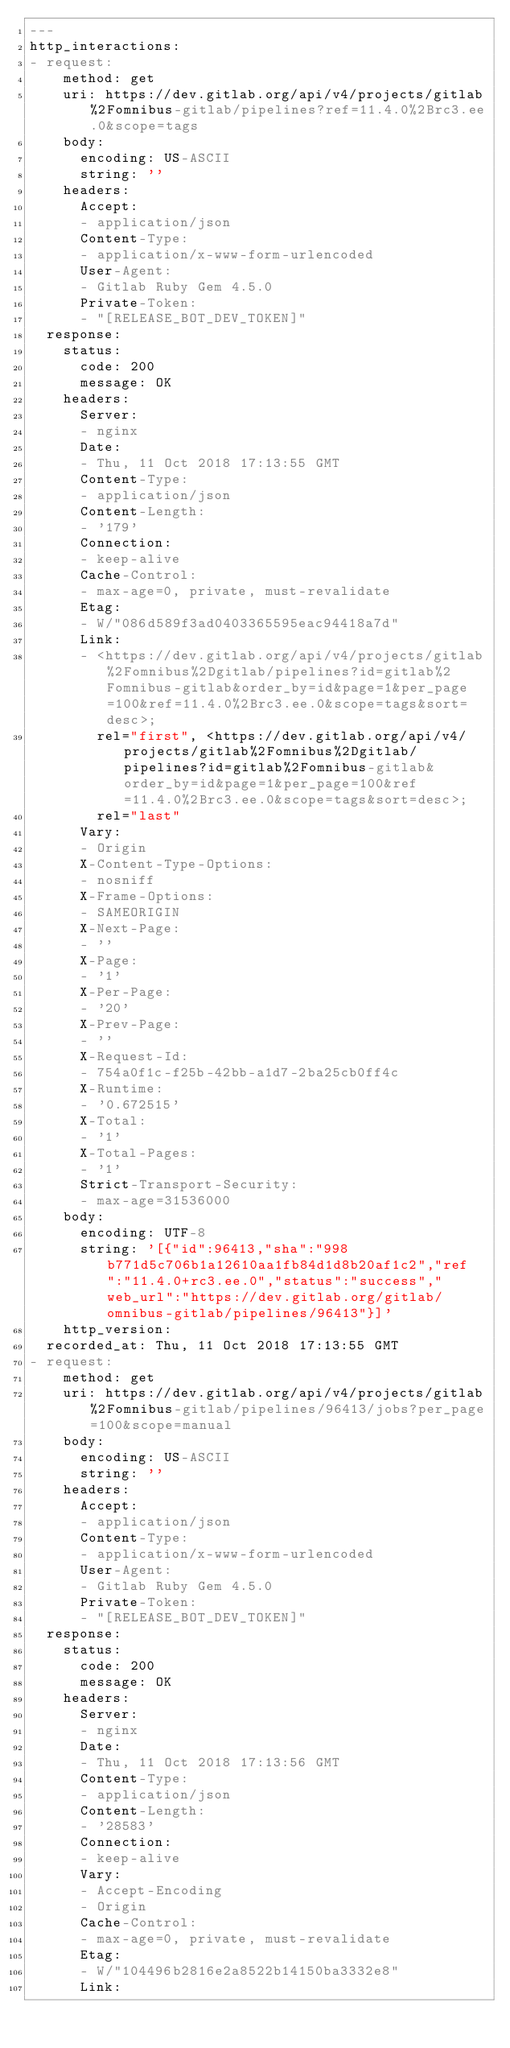Convert code to text. <code><loc_0><loc_0><loc_500><loc_500><_YAML_>---
http_interactions:
- request:
    method: get
    uri: https://dev.gitlab.org/api/v4/projects/gitlab%2Fomnibus-gitlab/pipelines?ref=11.4.0%2Brc3.ee.0&scope=tags
    body:
      encoding: US-ASCII
      string: ''
    headers:
      Accept:
      - application/json
      Content-Type:
      - application/x-www-form-urlencoded
      User-Agent:
      - Gitlab Ruby Gem 4.5.0
      Private-Token:
      - "[RELEASE_BOT_DEV_TOKEN]"
  response:
    status:
      code: 200
      message: OK
    headers:
      Server:
      - nginx
      Date:
      - Thu, 11 Oct 2018 17:13:55 GMT
      Content-Type:
      - application/json
      Content-Length:
      - '179'
      Connection:
      - keep-alive
      Cache-Control:
      - max-age=0, private, must-revalidate
      Etag:
      - W/"086d589f3ad0403365595eac94418a7d"
      Link:
      - <https://dev.gitlab.org/api/v4/projects/gitlab%2Fomnibus%2Dgitlab/pipelines?id=gitlab%2Fomnibus-gitlab&order_by=id&page=1&per_page=100&ref=11.4.0%2Brc3.ee.0&scope=tags&sort=desc>;
        rel="first", <https://dev.gitlab.org/api/v4/projects/gitlab%2Fomnibus%2Dgitlab/pipelines?id=gitlab%2Fomnibus-gitlab&order_by=id&page=1&per_page=100&ref=11.4.0%2Brc3.ee.0&scope=tags&sort=desc>;
        rel="last"
      Vary:
      - Origin
      X-Content-Type-Options:
      - nosniff
      X-Frame-Options:
      - SAMEORIGIN
      X-Next-Page:
      - ''
      X-Page:
      - '1'
      X-Per-Page:
      - '20'
      X-Prev-Page:
      - ''
      X-Request-Id:
      - 754a0f1c-f25b-42bb-a1d7-2ba25cb0ff4c
      X-Runtime:
      - '0.672515'
      X-Total:
      - '1'
      X-Total-Pages:
      - '1'
      Strict-Transport-Security:
      - max-age=31536000
    body:
      encoding: UTF-8
      string: '[{"id":96413,"sha":"998b771d5c706b1a12610aa1fb84d1d8b20af1c2","ref":"11.4.0+rc3.ee.0","status":"success","web_url":"https://dev.gitlab.org/gitlab/omnibus-gitlab/pipelines/96413"}]'
    http_version: 
  recorded_at: Thu, 11 Oct 2018 17:13:55 GMT
- request:
    method: get
    uri: https://dev.gitlab.org/api/v4/projects/gitlab%2Fomnibus-gitlab/pipelines/96413/jobs?per_page=100&scope=manual
    body:
      encoding: US-ASCII
      string: ''
    headers:
      Accept:
      - application/json
      Content-Type:
      - application/x-www-form-urlencoded
      User-Agent:
      - Gitlab Ruby Gem 4.5.0
      Private-Token:
      - "[RELEASE_BOT_DEV_TOKEN]"
  response:
    status:
      code: 200
      message: OK
    headers:
      Server:
      - nginx
      Date:
      - Thu, 11 Oct 2018 17:13:56 GMT
      Content-Type:
      - application/json
      Content-Length:
      - '28583'
      Connection:
      - keep-alive
      Vary:
      - Accept-Encoding
      - Origin
      Cache-Control:
      - max-age=0, private, must-revalidate
      Etag:
      - W/"104496b2816e2a8522b14150ba3332e8"
      Link:</code> 